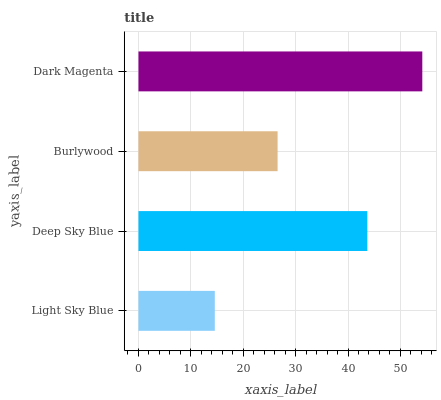Is Light Sky Blue the minimum?
Answer yes or no. Yes. Is Dark Magenta the maximum?
Answer yes or no. Yes. Is Deep Sky Blue the minimum?
Answer yes or no. No. Is Deep Sky Blue the maximum?
Answer yes or no. No. Is Deep Sky Blue greater than Light Sky Blue?
Answer yes or no. Yes. Is Light Sky Blue less than Deep Sky Blue?
Answer yes or no. Yes. Is Light Sky Blue greater than Deep Sky Blue?
Answer yes or no. No. Is Deep Sky Blue less than Light Sky Blue?
Answer yes or no. No. Is Deep Sky Blue the high median?
Answer yes or no. Yes. Is Burlywood the low median?
Answer yes or no. Yes. Is Light Sky Blue the high median?
Answer yes or no. No. Is Dark Magenta the low median?
Answer yes or no. No. 